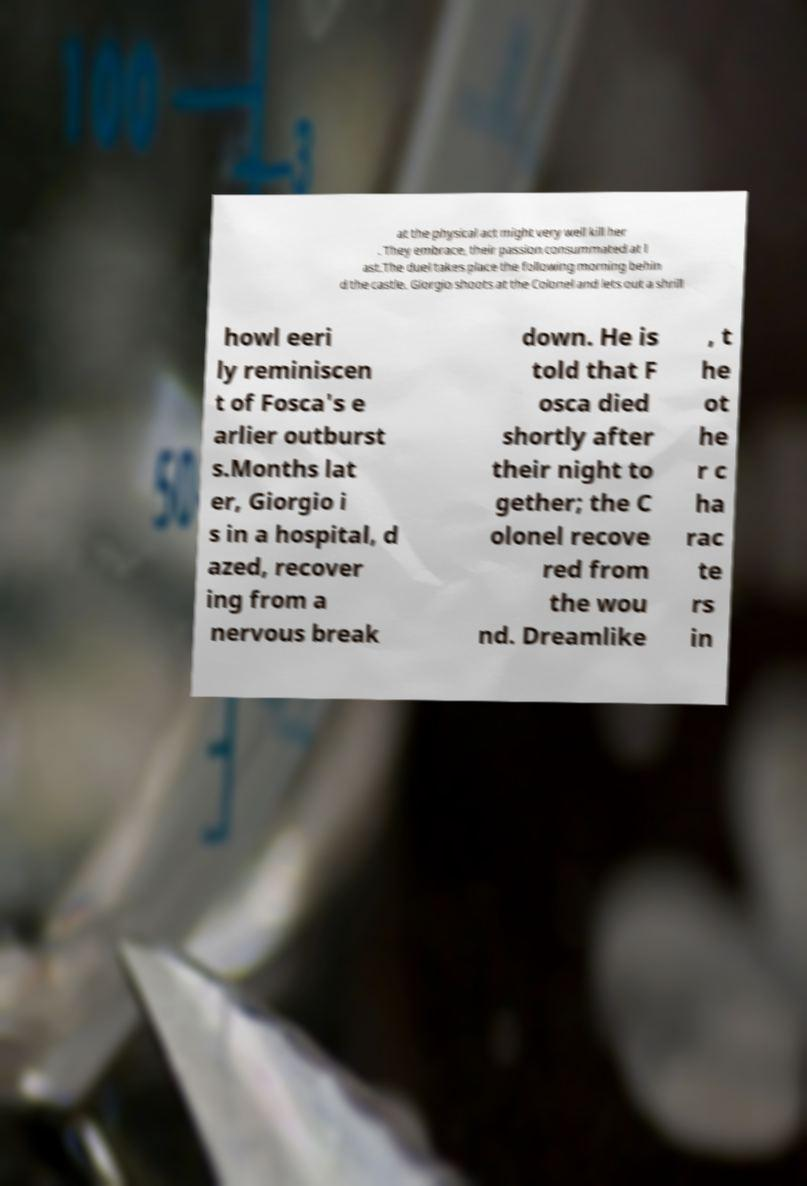For documentation purposes, I need the text within this image transcribed. Could you provide that? at the physical act might very well kill her . They embrace, their passion consummated at l ast.The duel takes place the following morning behin d the castle. Giorgio shoots at the Colonel and lets out a shrill howl eeri ly reminiscen t of Fosca's e arlier outburst s.Months lat er, Giorgio i s in a hospital, d azed, recover ing from a nervous break down. He is told that F osca died shortly after their night to gether; the C olonel recove red from the wou nd. Dreamlike , t he ot he r c ha rac te rs in 